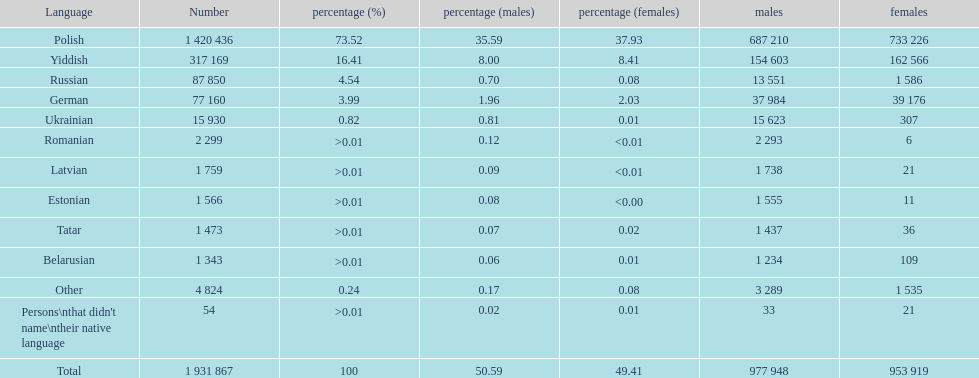Is german above or below russia in the number of people who speak that language? Below. 